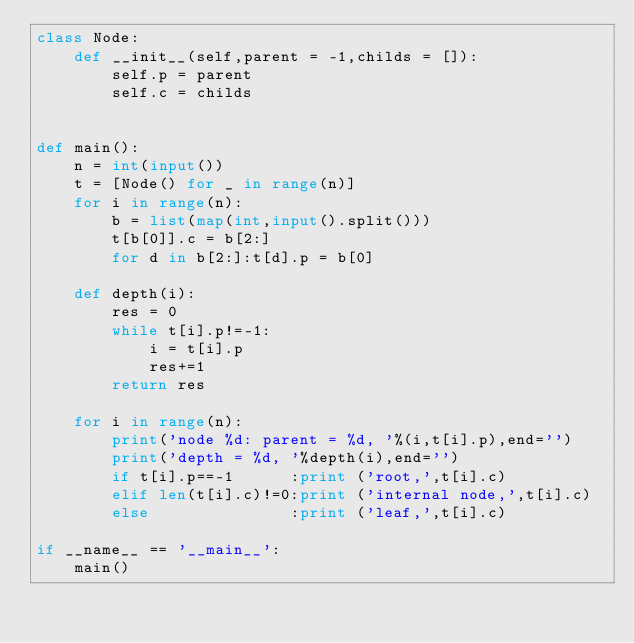Convert code to text. <code><loc_0><loc_0><loc_500><loc_500><_Python_>class Node:
    def __init__(self,parent = -1,childs = []):
        self.p = parent
        self.c = childs


def main():
    n = int(input())
    t = [Node() for _ in range(n)]
    for i in range(n):
        b = list(map(int,input().split()))
        t[b[0]].c = b[2:]
        for d in b[2:]:t[d].p = b[0]

    def depth(i):
        res = 0
        while t[i].p!=-1:
            i = t[i].p
            res+=1
        return res

    for i in range(n):
        print('node %d: parent = %d, '%(i,t[i].p),end='')
        print('depth = %d, '%depth(i),end='')
        if t[i].p==-1      :print ('root,',t[i].c)
        elif len(t[i].c)!=0:print ('internal node,',t[i].c)
        else               :print ('leaf,',t[i].c)

if __name__ == '__main__':
    main()


</code> 